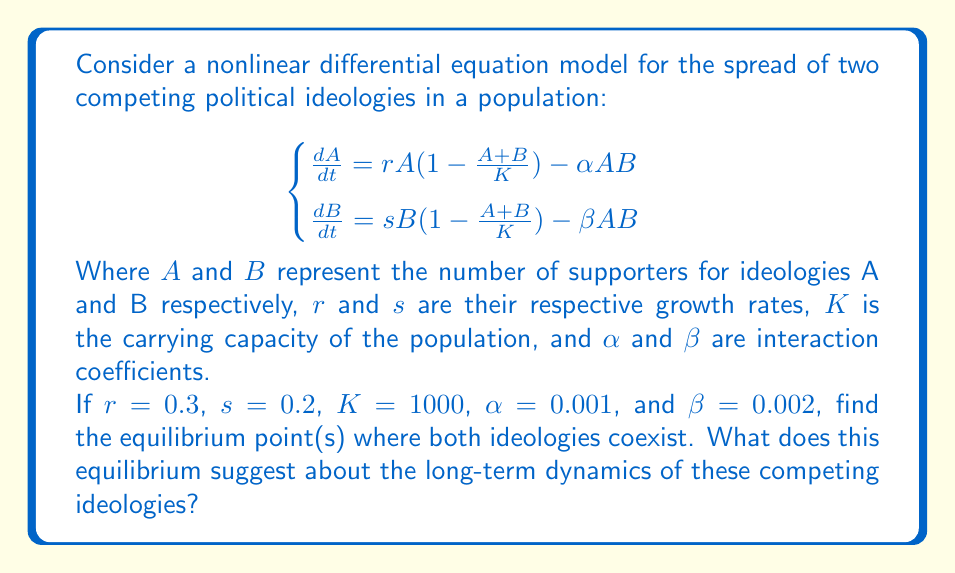Show me your answer to this math problem. To find the equilibrium points, we set both equations equal to zero and solve:

1) $\frac{dA}{dt} = 0$ and $\frac{dB}{dt} = 0$

2) $0.3A(1-\frac{A+B}{1000}) - 0.001AB = 0$ ... (1)
   $0.2B(1-\frac{A+B}{1000}) - 0.002AB = 0$ ... (2)

3) From (1): $0.3(1-\frac{A+B}{1000}) = 0.001B$
   $0.3 - 0.0003A - 0.0003B = 0.001B$
   $0.3 - 0.0003A = 0.0013B$
   $A = 1000 - 4.33B$ ... (3)

4) Substitute (3) into (2):
   $0.2B(1-\frac{(1000-4.33B)+B}{1000}) - 0.002B(1000-4.33B) = 0$
   $0.2B(1-\frac{1000-3.33B}{1000}) - 2B + 0.00866B^2 = 0$
   $0.2B(\frac{3.33B}{1000}) - 2B + 0.00866B^2 = 0$
   $0.000666B^2 - 2B + 0.00866B^2 = 0$
   $0.009326B^2 - 2B = 0$
   $B(0.009326B - 2) = 0$

5) Solving this equation:
   $B = 0$ or $B = 214.5$

6) If $B = 214.5$, then from (3):
   $A = 1000 - 4.33(214.5) = 71.2$

Therefore, the non-trivial equilibrium point is approximately (71.2, 214.5).

This equilibrium suggests that in the long term, ideology B will have more supporters than ideology A, with a ratio of about 3:1. The coexistence equilibrium indicates that neither ideology will completely dominate or eliminate the other under these conditions.
Answer: Equilibrium point: (71.2, 214.5) 